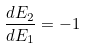Convert formula to latex. <formula><loc_0><loc_0><loc_500><loc_500>\frac { d E _ { 2 } } { d E _ { 1 } } = - 1</formula> 